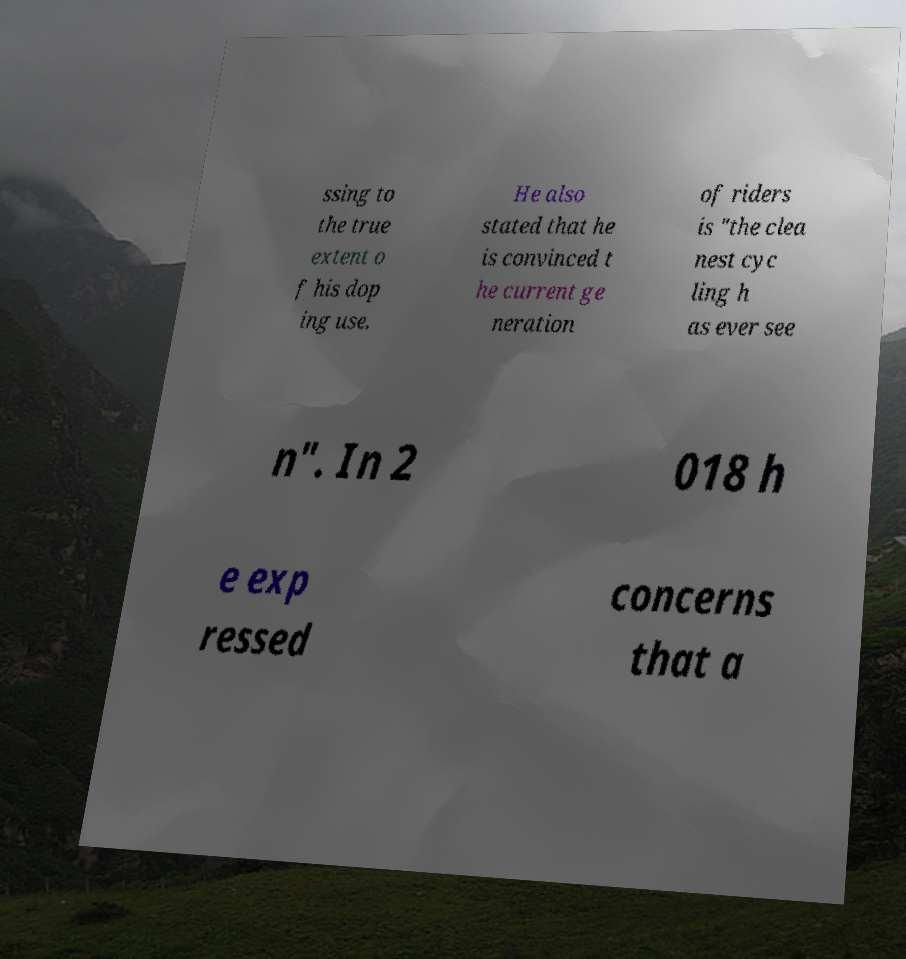Can you accurately transcribe the text from the provided image for me? ssing to the true extent o f his dop ing use. He also stated that he is convinced t he current ge neration of riders is "the clea nest cyc ling h as ever see n". In 2 018 h e exp ressed concerns that a 